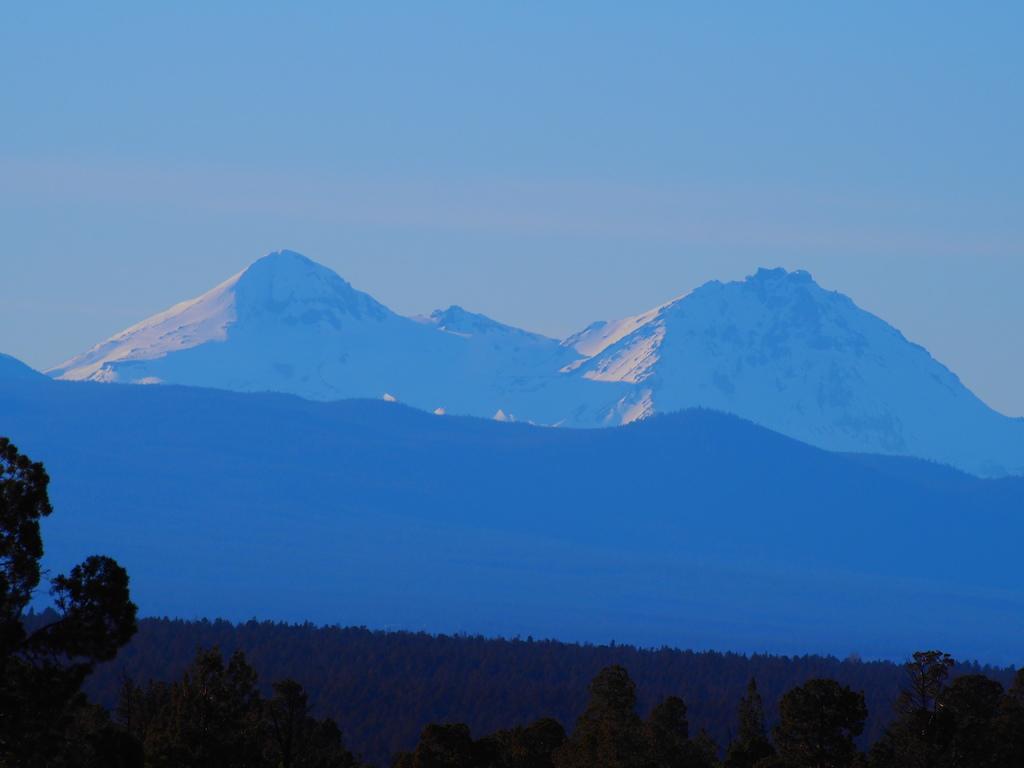Describe this image in one or two sentences. In this picture I can see the trees in front and in the background I can see the mountains and the sky. 